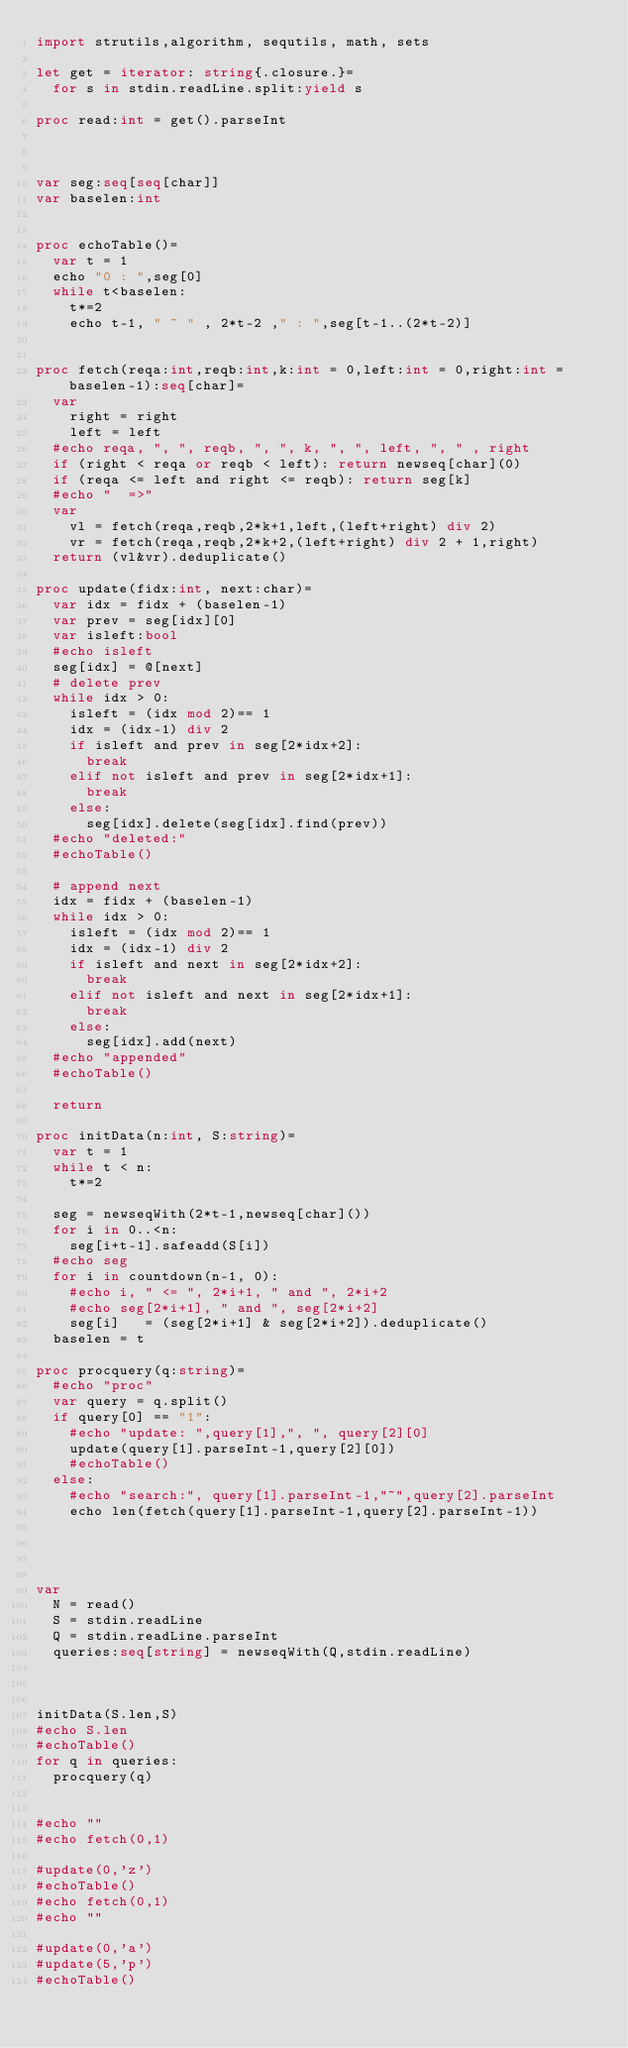<code> <loc_0><loc_0><loc_500><loc_500><_Nim_>import strutils,algorithm, sequtils, math, sets

let get = iterator: string{.closure.}=
  for s in stdin.readLine.split:yield s

proc read:int = get().parseInt



var seg:seq[seq[char]]
var baselen:int


proc echoTable()=
  var t = 1
  echo "0 : ",seg[0]
  while t<baselen:
    t*=2
    echo t-1, " ~ " , 2*t-2 ," : ",seg[t-1..(2*t-2)]


proc fetch(reqa:int,reqb:int,k:int = 0,left:int = 0,right:int = baselen-1):seq[char]=
  var
    right = right
    left = left
  #echo reqa, ", ", reqb, ", ", k, ", ", left, ", " , right
  if (right < reqa or reqb < left): return newseq[char](0)
  if (reqa <= left and right <= reqb): return seg[k]
  #echo "  =>"
  var 
    vl = fetch(reqa,reqb,2*k+1,left,(left+right) div 2)
    vr = fetch(reqa,reqb,2*k+2,(left+right) div 2 + 1,right)
  return (vl&vr).deduplicate()

proc update(fidx:int, next:char)=
  var idx = fidx + (baselen-1)
  var prev = seg[idx][0]
  var isleft:bool
  #echo isleft
  seg[idx] = @[next]
  # delete prev
  while idx > 0:
    isleft = (idx mod 2)== 1
    idx = (idx-1) div 2
    if isleft and prev in seg[2*idx+2]:
      break
    elif not isleft and prev in seg[2*idx+1]:
      break
    else:
      seg[idx].delete(seg[idx].find(prev))
  #echo "deleted:"
  #echoTable()

  # append next
  idx = fidx + (baselen-1)
  while idx > 0:
    isleft = (idx mod 2)== 1
    idx = (idx-1) div 2
    if isleft and next in seg[2*idx+2]:
      break
    elif not isleft and next in seg[2*idx+1]:
      break
    else:
      seg[idx].add(next)
  #echo "appended"
  #echoTable()

  return

proc initData(n:int, S:string)=
  var t = 1
  while t < n:
    t*=2

  seg = newseqWith(2*t-1,newseq[char]())
  for i in 0..<n:
    seg[i+t-1].safeadd(S[i])
  #echo seg
  for i in countdown(n-1, 0):
    #echo i, " <= ", 2*i+1, " and ", 2*i+2
    #echo seg[2*i+1], " and ", seg[2*i+2]
    seg[i]   = (seg[2*i+1] & seg[2*i+2]).deduplicate()
  baselen = t

proc procquery(q:string)=
  #echo "proc"
  var query = q.split()
  if query[0] == "1":
    #echo "update: ",query[1],", ", query[2][0]
    update(query[1].parseInt-1,query[2][0])
    #echoTable()
  else:
    #echo "search:", query[1].parseInt-1,"~",query[2].parseInt
    echo len(fetch(query[1].parseInt-1,query[2].parseInt-1))




var
  N = read()
  S = stdin.readLine
  Q = stdin.readLine.parseInt
  queries:seq[string] = newseqWith(Q,stdin.readLine)



initData(S.len,S)
#echo S.len
#echoTable()
for q in queries:
  procquery(q)


#echo ""
#echo fetch(0,1)

#update(0,'z')
#echoTable()
#echo fetch(0,1)
#echo ""

#update(0,'a')
#update(5,'p')
#echoTable()</code> 